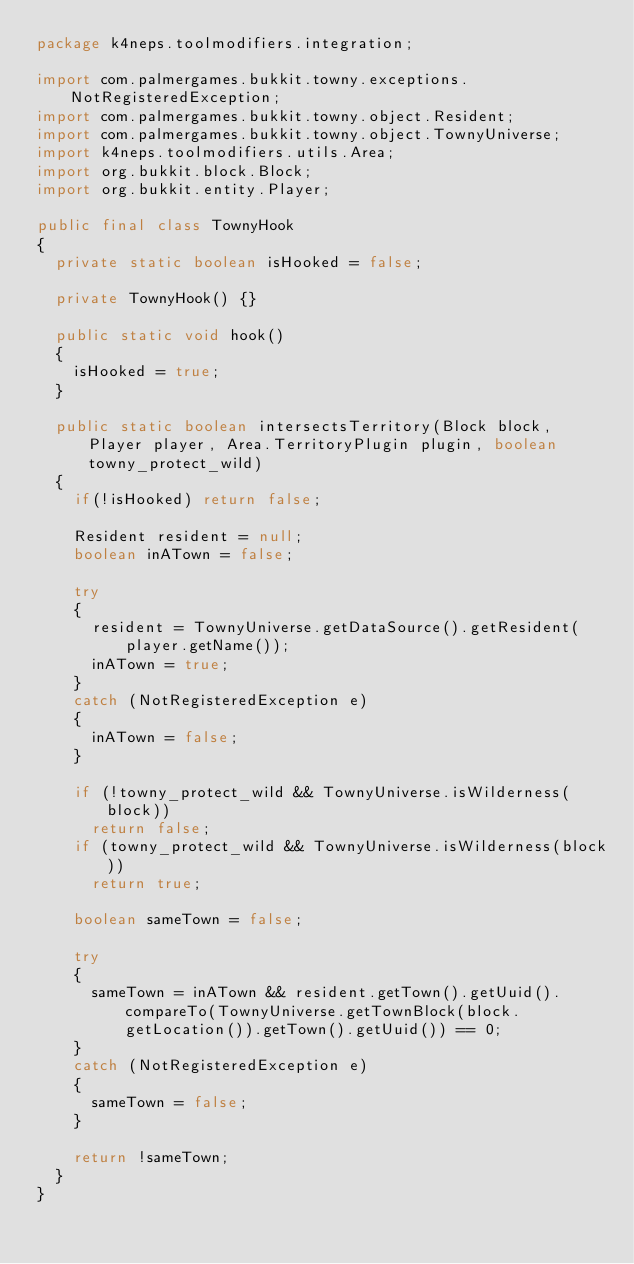Convert code to text. <code><loc_0><loc_0><loc_500><loc_500><_Java_>package k4neps.toolmodifiers.integration;

import com.palmergames.bukkit.towny.exceptions.NotRegisteredException;
import com.palmergames.bukkit.towny.object.Resident;
import com.palmergames.bukkit.towny.object.TownyUniverse;
import k4neps.toolmodifiers.utils.Area;
import org.bukkit.block.Block;
import org.bukkit.entity.Player;

public final class TownyHook
{
	private static boolean isHooked = false;

	private TownyHook() {}

	public static void hook()
	{
		isHooked = true;
	}

	public static boolean intersectsTerritory(Block block, Player player, Area.TerritoryPlugin plugin, boolean towny_protect_wild)
	{
		if(!isHooked) return false;

		Resident resident = null;
		boolean inATown = false;

		try
		{
			resident = TownyUniverse.getDataSource().getResident(player.getName());
			inATown = true;
		}
		catch (NotRegisteredException e)
		{
			inATown = false;
		}

		if (!towny_protect_wild && TownyUniverse.isWilderness(block))
			return false;
		if (towny_protect_wild && TownyUniverse.isWilderness(block))
			return true;

		boolean sameTown = false;

		try
		{
			sameTown = inATown && resident.getTown().getUuid().compareTo(TownyUniverse.getTownBlock(block.getLocation()).getTown().getUuid()) == 0;
		}
		catch (NotRegisteredException e)
		{
			sameTown = false;
		}

		return !sameTown;
	}
}
</code> 